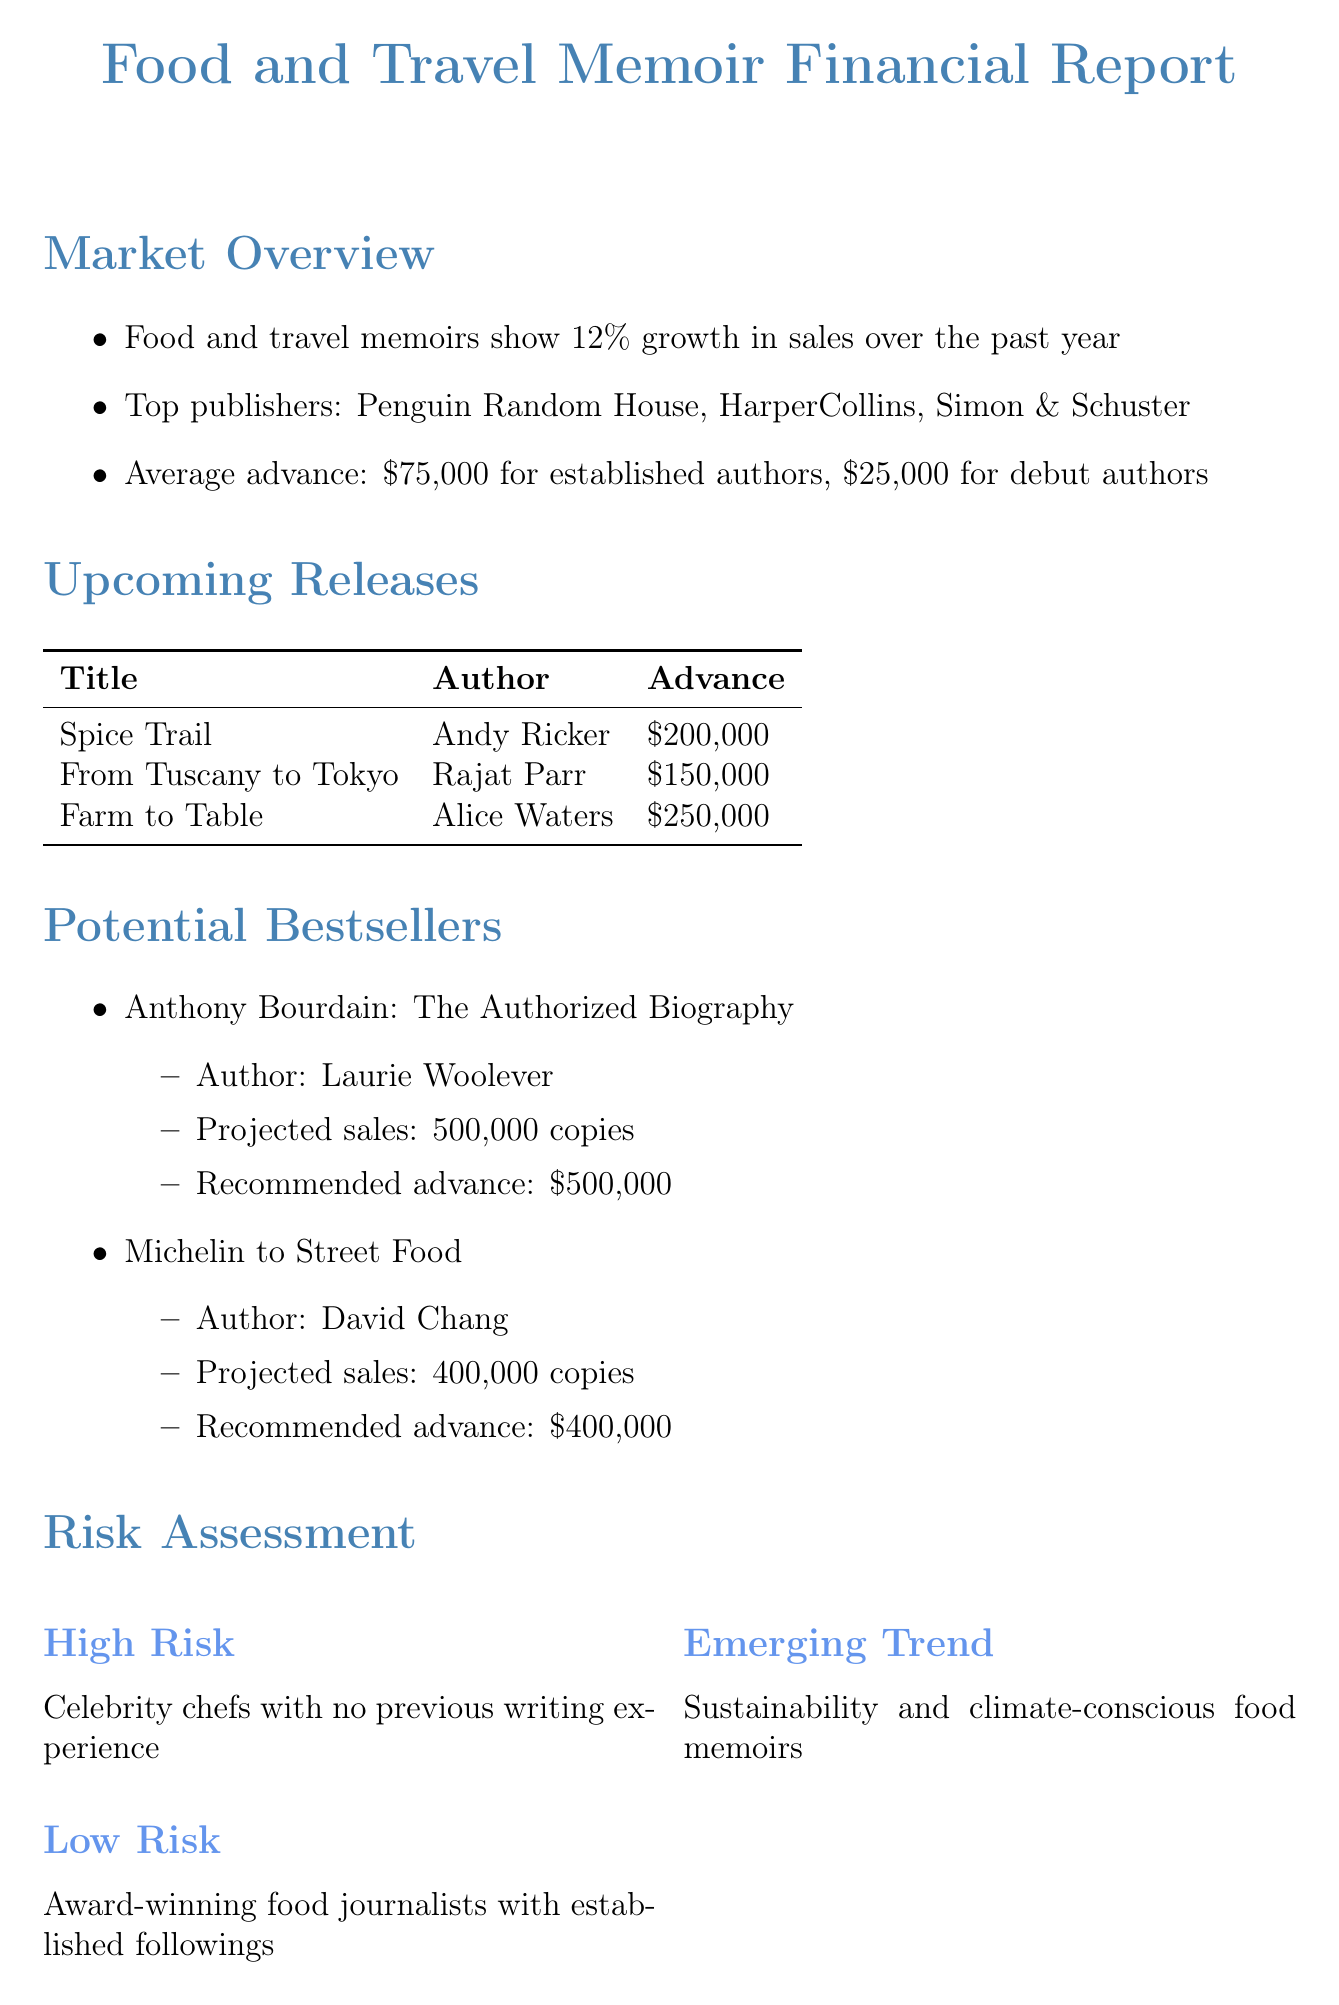What is the average advance for established authors? The average advance for established authors is stated in the market overview section of the document.
Answer: $75,000 How many copies are projected to be sold of "Farm to Table: My Year of Sustainable Eating Across America"? The projected sales for "Farm to Table" are specified in the upcoming releases section.
Answer: 300,000 copies What is the total advance budget for the upcoming fiscal year? The total advance budget is mentioned in the financial projections section of the document.
Answer: $2,500,000 Who is the author of "Michelin to Street Food: A Journey Through France's Culinary Revolution"? The author is listed alongside the title in the potential bestsellers section.
Answer: David Chang What is the average number of copies that need to be sold to break even? The breakeven point is provided in the financial projections section and needs to be computed from the information given.
Answer: Average of 50,000 copies sold per title Why are celebrity chefs with no previous writing experience considered high risk? The risk assessment section discusses the high-risk category along with its rationale.
Answer: High risk What is the expected ROI from food and travel memoirs? The expected ROI is specified in the financial projections section of the document.
Answer: 25% increase What type of authors are deemed low risk? The risk assessment section identifies authors with a specific characteristic as low risk.
Answer: Award-winning food journalists 